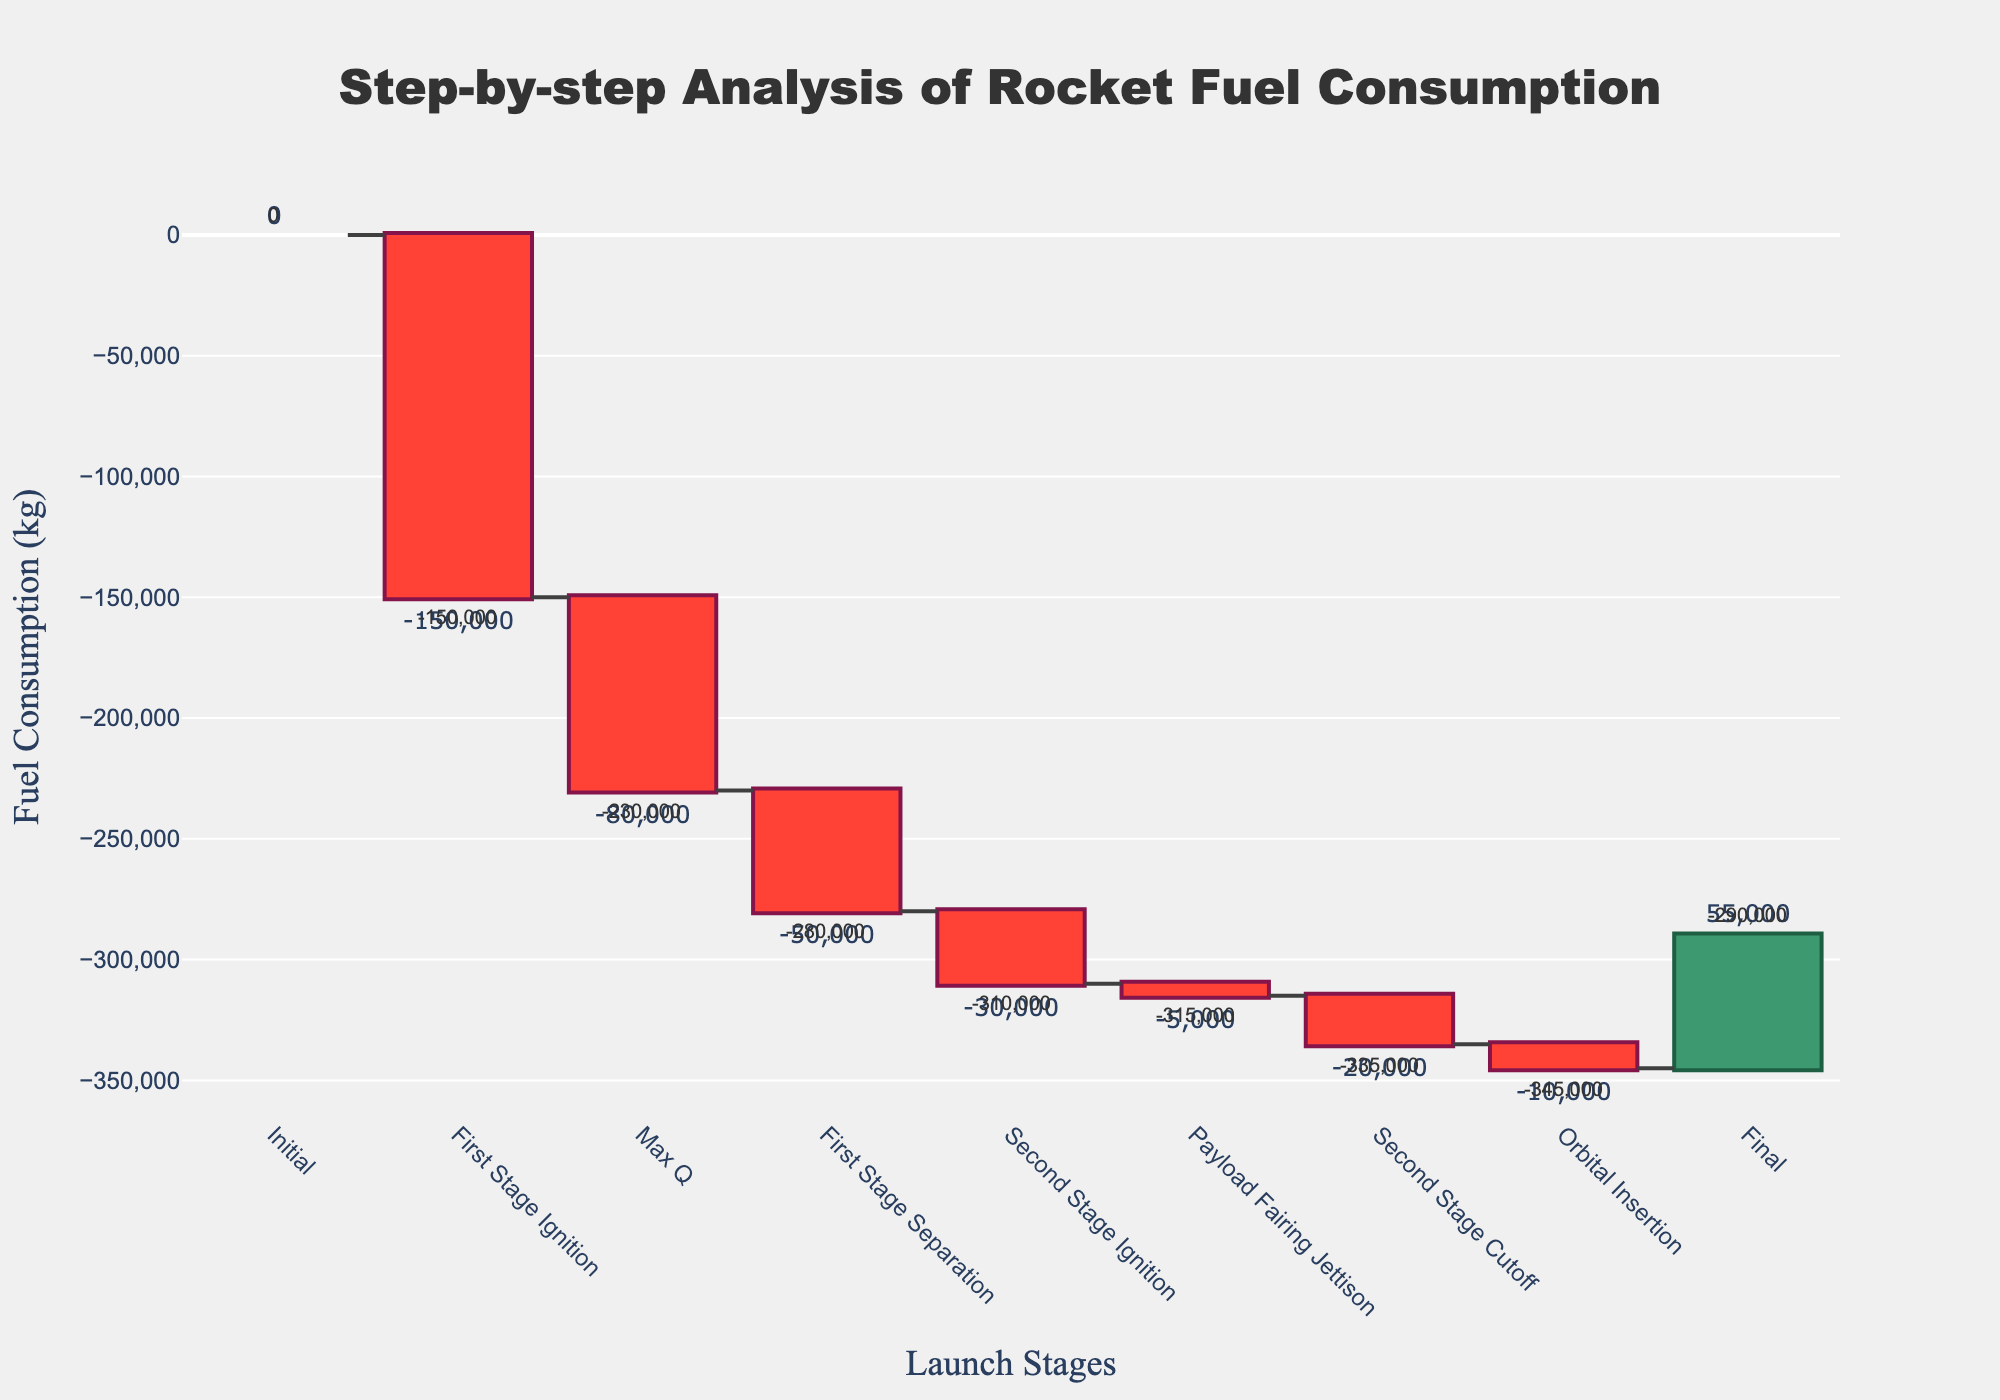What's the title of the chart? The title is displayed at the top of the chart in a prominent font.
Answer: Step-by-step Analysis of Rocket Fuel Consumption Which stage has the highest fuel consumption? The highest negative value on the y-axis corresponds to the highest fuel consumption, which is during the "First Stage Ignition" stage.
Answer: First Stage Ignition What is the final cumulative fuel consumption value? The final cumulative value is displayed at the "Final" stage at the end of the waterfall chart.
Answer: 55,000 kg What is the cumulative fuel consumption after "Max Q"? The cumulative value at "Max Q" is displayed as an annotation near that stage on the chart.
Answer: -230,000 kg Which stage shows an increase in the chart? The stage with a positive value on the y-axis in the chart shows an increase, which is the "Final" stage.
Answer: Final How does the fuel consumption during "Second Stage Cutoff" compare to "Payload Fairing Jettison"? Compare the fuel consumption values at these stages. "Second Stage Cutoff" has a fuel consumption of -20,000 kg, and "Payload Fairing Jettison" has -5,000 kg.
Answer: -20,000 kg is less than -5,000 kg What pattern is observed about the cumulative fuel consumption trend in the chart? The chart shows a stepwise pattern of negative decreases followed by a final positive increase, indicating the cumulative reduction in fuel consumption during stages with the final stage's value going positive.
Answer: Stepwise decrease with a final increase What is the cumulative fuel consumption value at "First Stage Separation"? The cumulative value at "First Stage Separation" is mentioned near that stage annotation.
Answer: -280,000 kg 